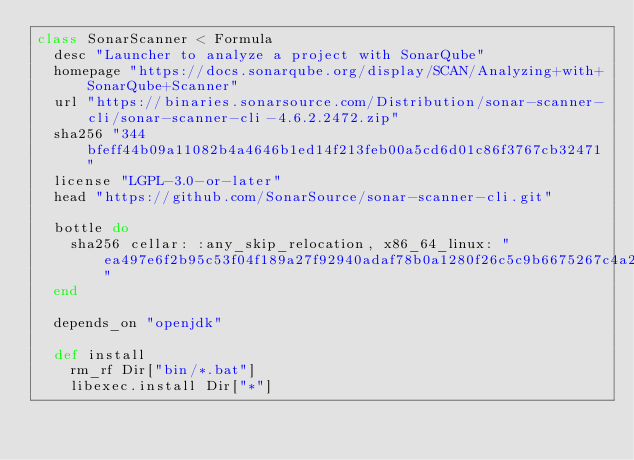Convert code to text. <code><loc_0><loc_0><loc_500><loc_500><_Ruby_>class SonarScanner < Formula
  desc "Launcher to analyze a project with SonarQube"
  homepage "https://docs.sonarqube.org/display/SCAN/Analyzing+with+SonarQube+Scanner"
  url "https://binaries.sonarsource.com/Distribution/sonar-scanner-cli/sonar-scanner-cli-4.6.2.2472.zip"
  sha256 "344bfeff44b09a11082b4a4646b1ed14f213feb00a5cd6d01c86f3767cb32471"
  license "LGPL-3.0-or-later"
  head "https://github.com/SonarSource/sonar-scanner-cli.git"

  bottle do
    sha256 cellar: :any_skip_relocation, x86_64_linux: "ea497e6f2b95c53f04f189a27f92940adaf78b0a1280f26c5c9b6675267c4a2e"
  end

  depends_on "openjdk"

  def install
    rm_rf Dir["bin/*.bat"]
    libexec.install Dir["*"]</code> 